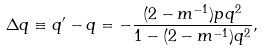<formula> <loc_0><loc_0><loc_500><loc_500>\Delta q \equiv q ^ { \prime } - q = - \frac { ( 2 - m ^ { - 1 } ) p q ^ { 2 } } { 1 - ( 2 - m ^ { - 1 } ) q ^ { 2 } } ,</formula> 